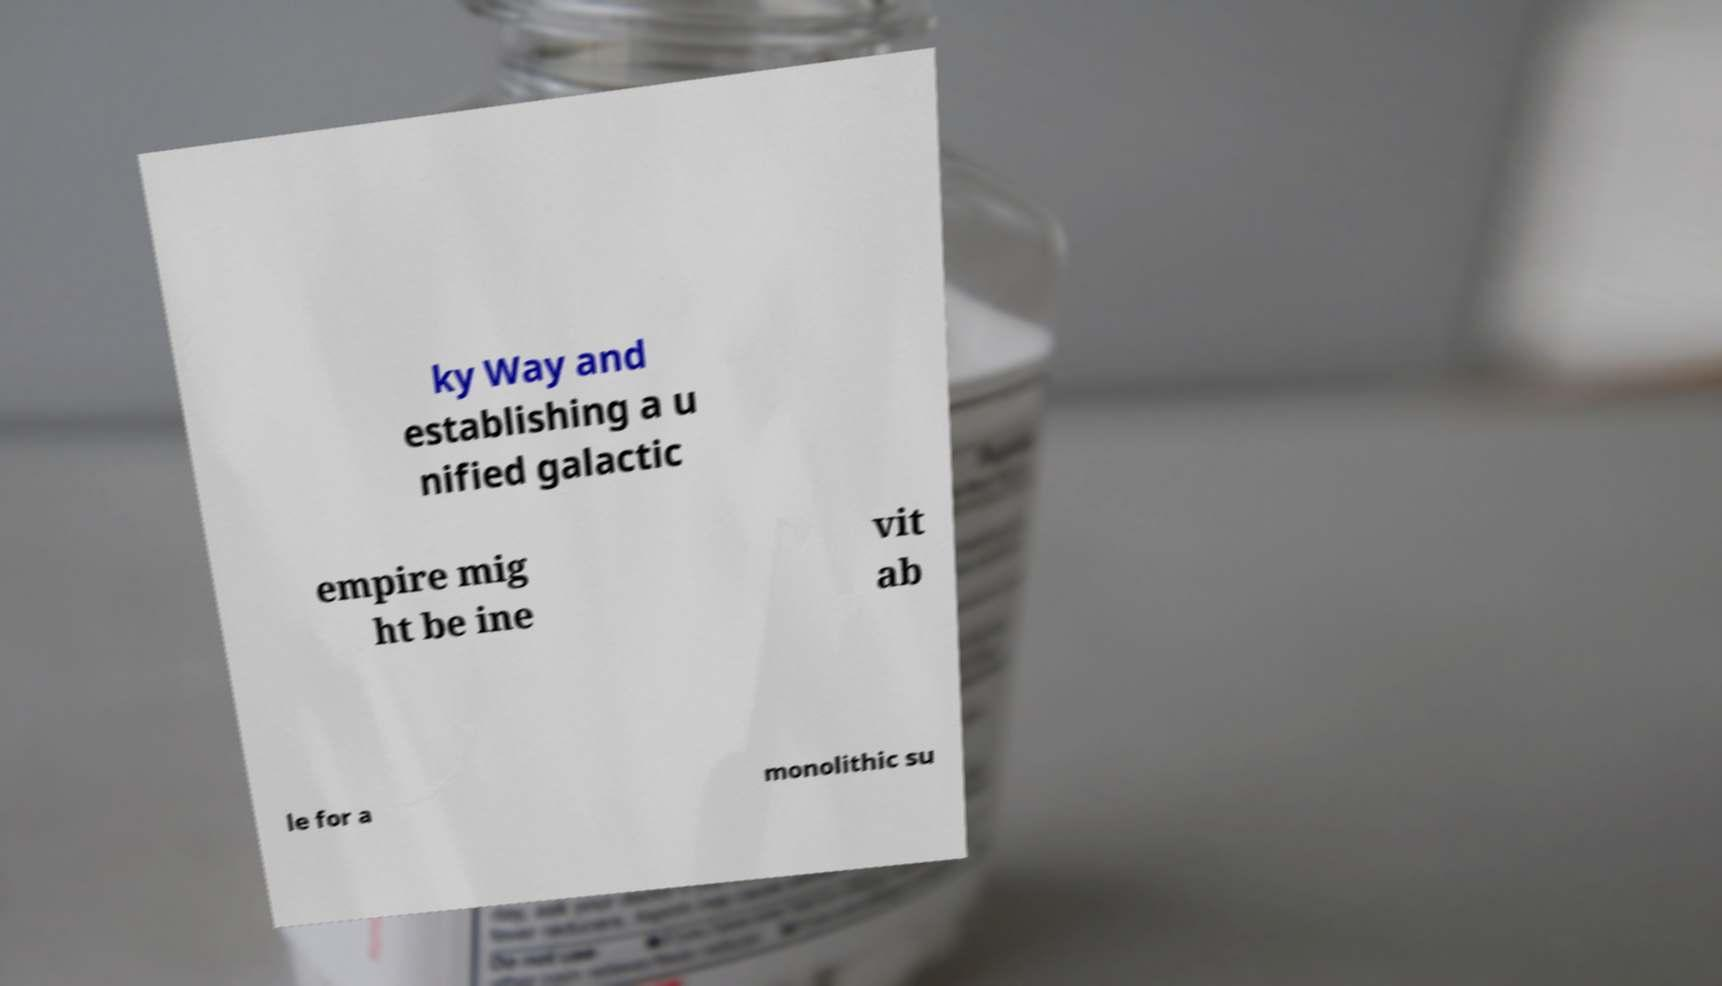Could you assist in decoding the text presented in this image and type it out clearly? ky Way and establishing a u nified galactic empire mig ht be ine vit ab le for a monolithic su 